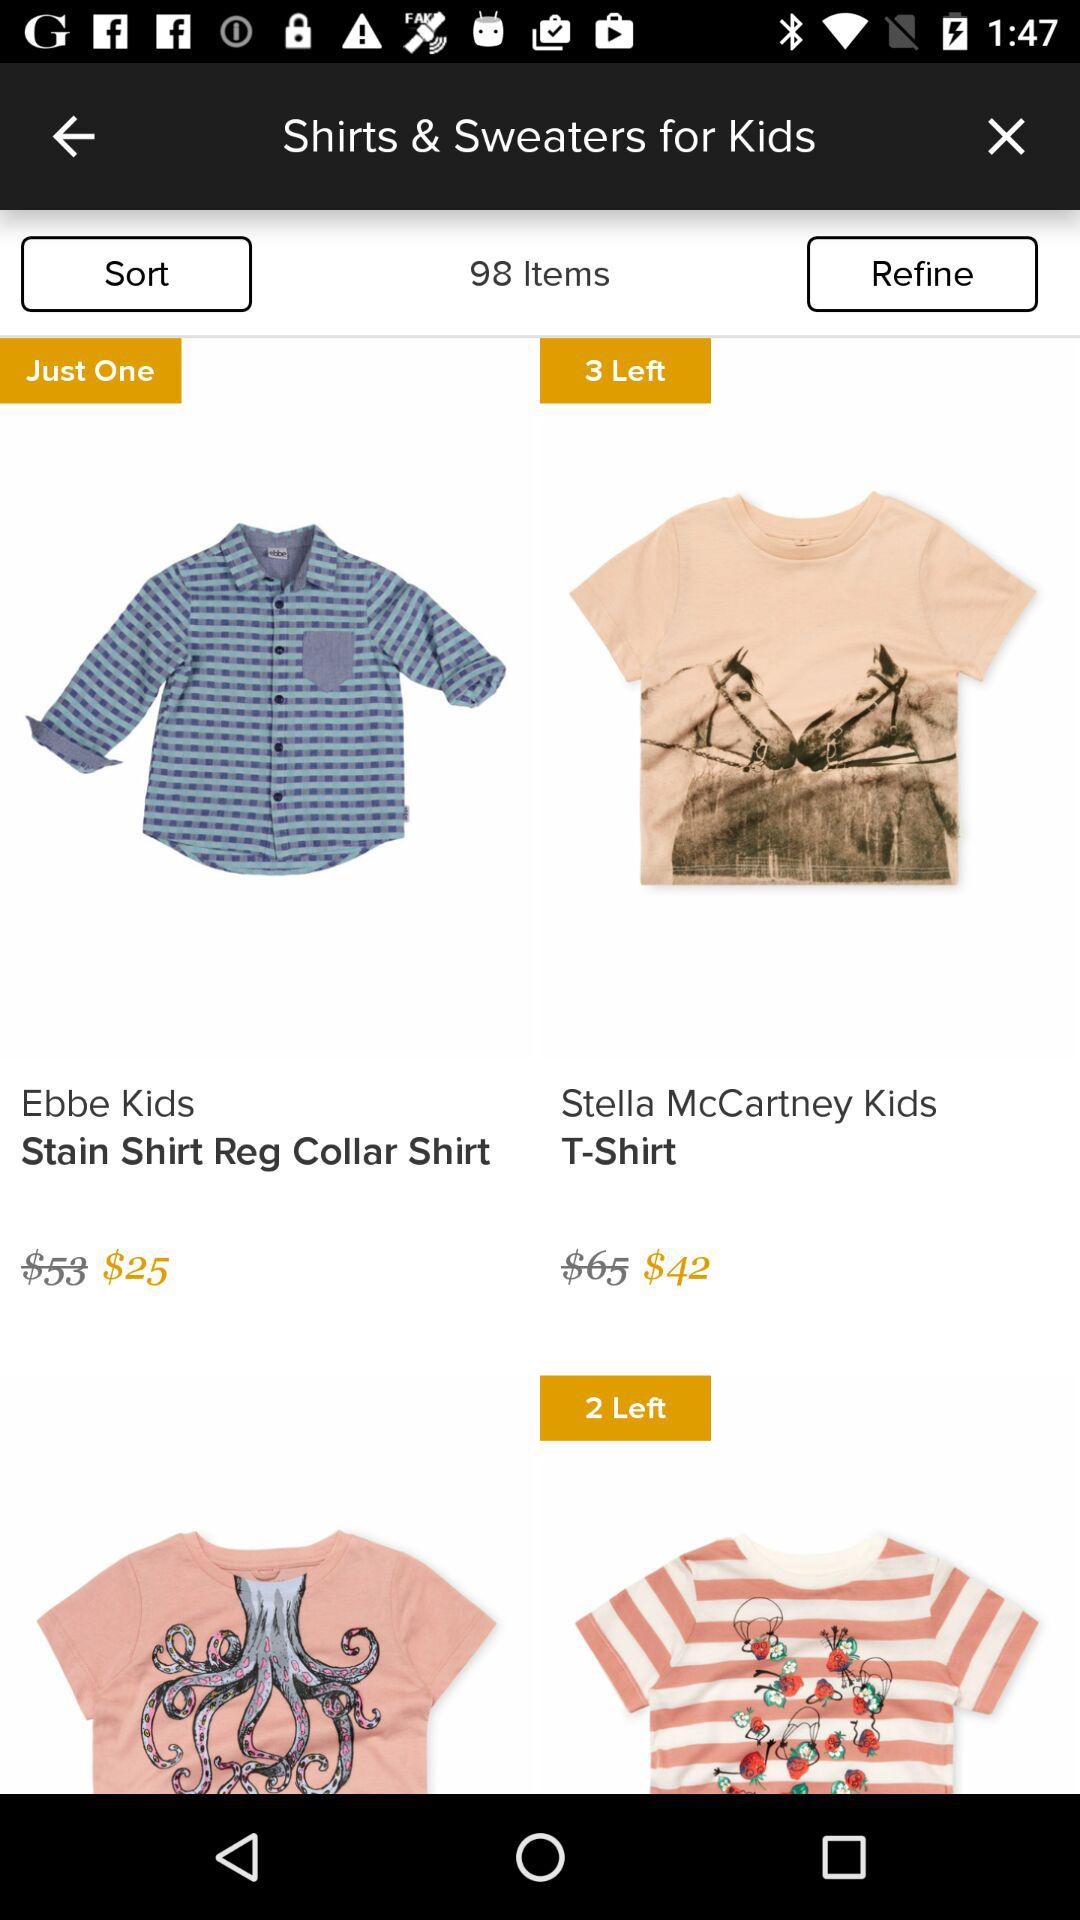How many Ebbe Kids' stain shirt regular collar shirts are left? There is one shirt left. 